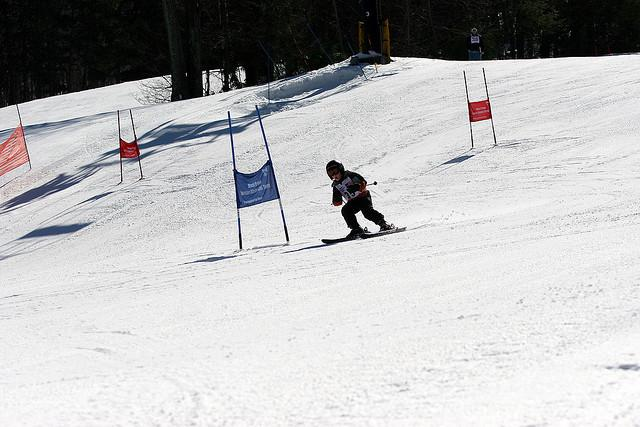What is the boy doing? skiing 